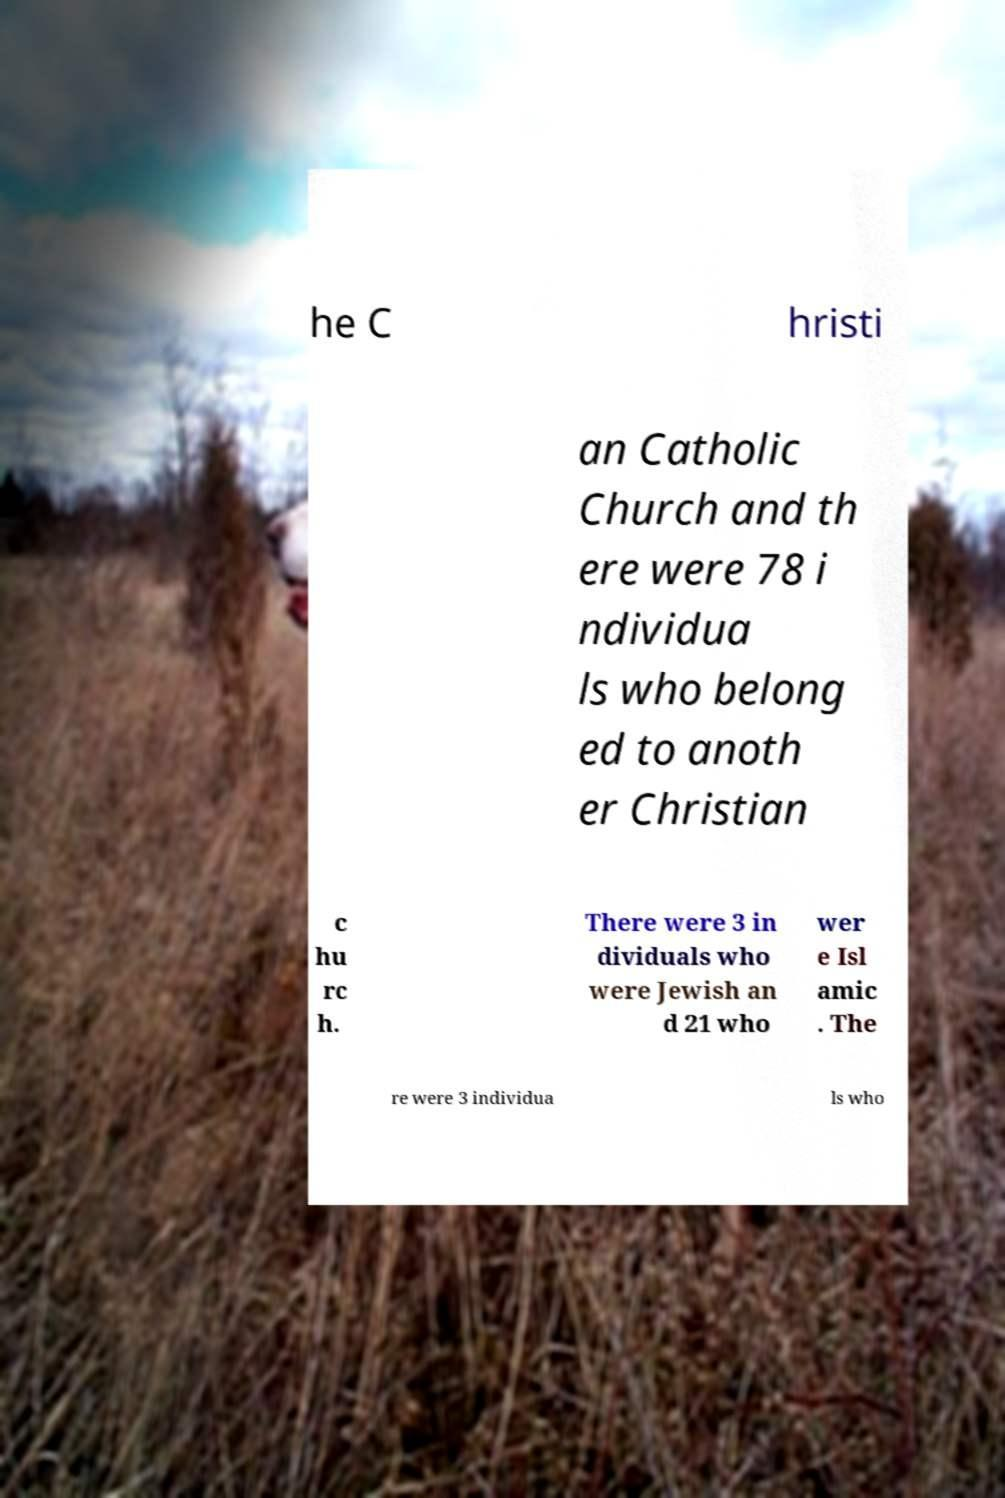I need the written content from this picture converted into text. Can you do that? he C hristi an Catholic Church and th ere were 78 i ndividua ls who belong ed to anoth er Christian c hu rc h. There were 3 in dividuals who were Jewish an d 21 who wer e Isl amic . The re were 3 individua ls who 